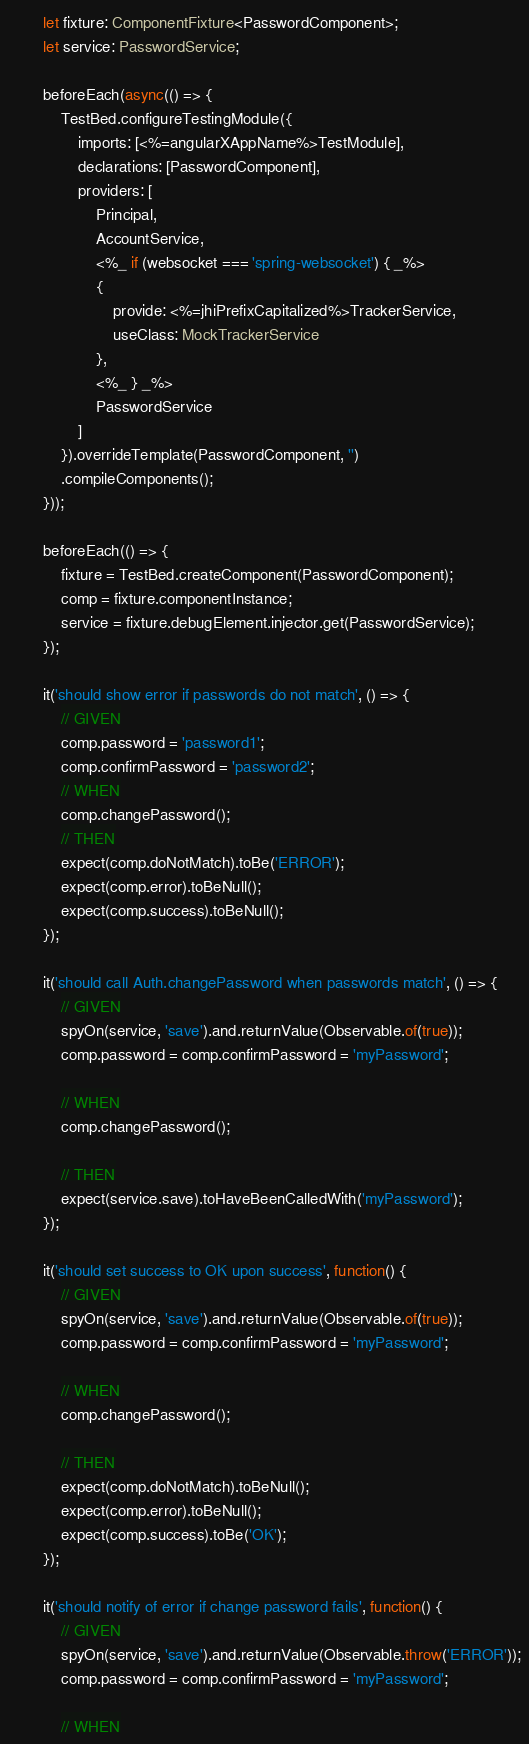<code> <loc_0><loc_0><loc_500><loc_500><_TypeScript_>        let fixture: ComponentFixture<PasswordComponent>;
        let service: PasswordService;

        beforeEach(async(() => {
            TestBed.configureTestingModule({
                imports: [<%=angularXAppName%>TestModule],
                declarations: [PasswordComponent],
                providers: [
                    Principal,
                    AccountService,
                    <%_ if (websocket === 'spring-websocket') { _%>
                    {
                        provide: <%=jhiPrefixCapitalized%>TrackerService,
                        useClass: MockTrackerService
                    },
                    <%_ } _%>
                    PasswordService
                ]
            }).overrideTemplate(PasswordComponent, '')
            .compileComponents();
        }));

        beforeEach(() => {
            fixture = TestBed.createComponent(PasswordComponent);
            comp = fixture.componentInstance;
            service = fixture.debugElement.injector.get(PasswordService);
        });

        it('should show error if passwords do not match', () => {
            // GIVEN
            comp.password = 'password1';
            comp.confirmPassword = 'password2';
            // WHEN
            comp.changePassword();
            // THEN
            expect(comp.doNotMatch).toBe('ERROR');
            expect(comp.error).toBeNull();
            expect(comp.success).toBeNull();
        });

        it('should call Auth.changePassword when passwords match', () => {
            // GIVEN
            spyOn(service, 'save').and.returnValue(Observable.of(true));
            comp.password = comp.confirmPassword = 'myPassword';

            // WHEN
            comp.changePassword();

            // THEN
            expect(service.save).toHaveBeenCalledWith('myPassword');
        });

        it('should set success to OK upon success', function() {
            // GIVEN
            spyOn(service, 'save').and.returnValue(Observable.of(true));
            comp.password = comp.confirmPassword = 'myPassword';

            // WHEN
            comp.changePassword();

            // THEN
            expect(comp.doNotMatch).toBeNull();
            expect(comp.error).toBeNull();
            expect(comp.success).toBe('OK');
        });

        it('should notify of error if change password fails', function() {
            // GIVEN
            spyOn(service, 'save').and.returnValue(Observable.throw('ERROR'));
            comp.password = comp.confirmPassword = 'myPassword';

            // WHEN</code> 